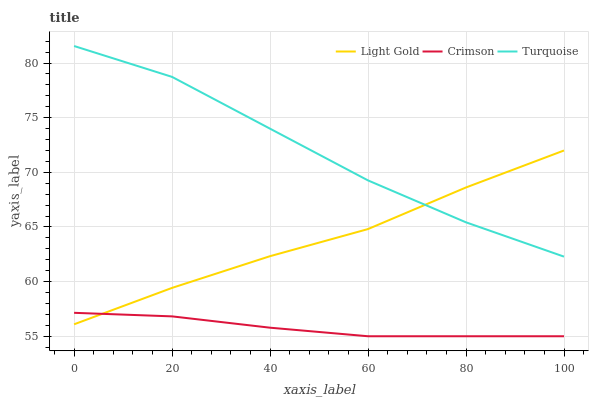Does Crimson have the minimum area under the curve?
Answer yes or no. Yes. Does Turquoise have the maximum area under the curve?
Answer yes or no. Yes. Does Light Gold have the minimum area under the curve?
Answer yes or no. No. Does Light Gold have the maximum area under the curve?
Answer yes or no. No. Is Crimson the smoothest?
Answer yes or no. Yes. Is Turquoise the roughest?
Answer yes or no. Yes. Is Light Gold the smoothest?
Answer yes or no. No. Is Light Gold the roughest?
Answer yes or no. No. Does Crimson have the lowest value?
Answer yes or no. Yes. Does Light Gold have the lowest value?
Answer yes or no. No. Does Turquoise have the highest value?
Answer yes or no. Yes. Does Light Gold have the highest value?
Answer yes or no. No. Is Crimson less than Turquoise?
Answer yes or no. Yes. Is Turquoise greater than Crimson?
Answer yes or no. Yes. Does Light Gold intersect Crimson?
Answer yes or no. Yes. Is Light Gold less than Crimson?
Answer yes or no. No. Is Light Gold greater than Crimson?
Answer yes or no. No. Does Crimson intersect Turquoise?
Answer yes or no. No. 